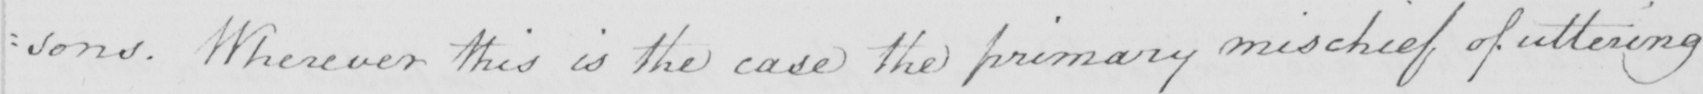Can you tell me what this handwritten text says? : sons . Wherever this is the case the primary mischief of uttering 